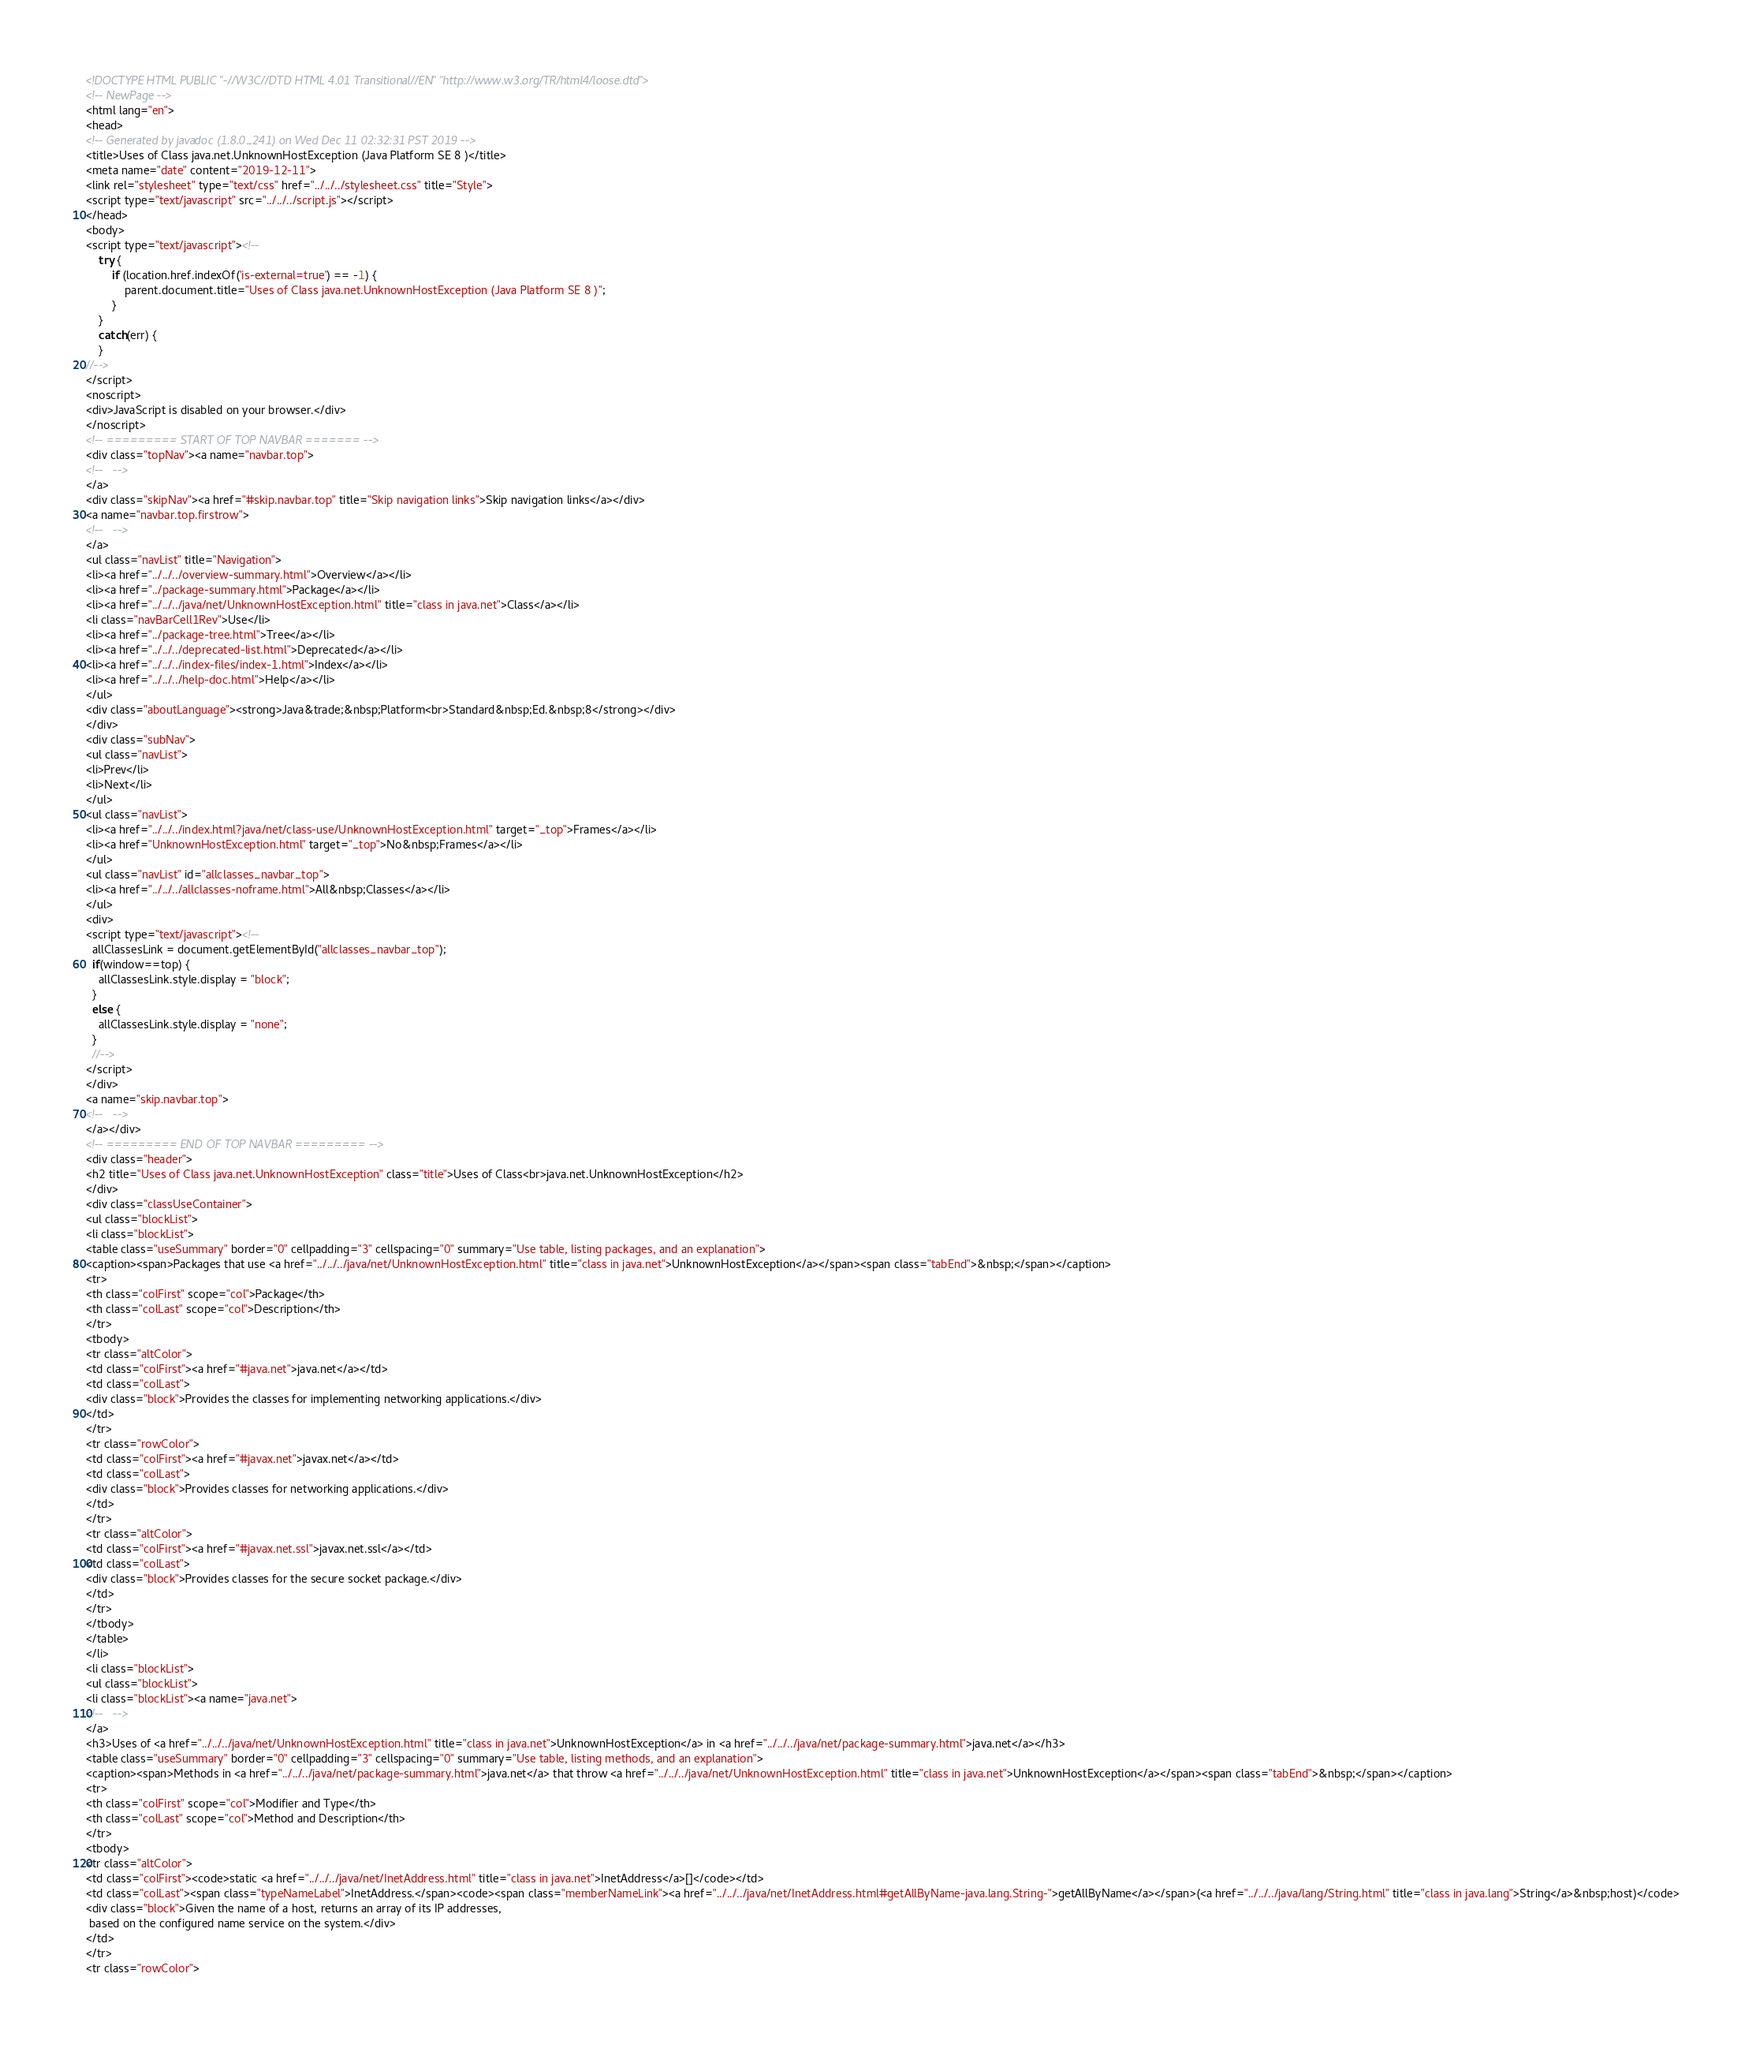Convert code to text. <code><loc_0><loc_0><loc_500><loc_500><_HTML_><!DOCTYPE HTML PUBLIC "-//W3C//DTD HTML 4.01 Transitional//EN" "http://www.w3.org/TR/html4/loose.dtd">
<!-- NewPage -->
<html lang="en">
<head>
<!-- Generated by javadoc (1.8.0_241) on Wed Dec 11 02:32:31 PST 2019 -->
<title>Uses of Class java.net.UnknownHostException (Java Platform SE 8 )</title>
<meta name="date" content="2019-12-11">
<link rel="stylesheet" type="text/css" href="../../../stylesheet.css" title="Style">
<script type="text/javascript" src="../../../script.js"></script>
</head>
<body>
<script type="text/javascript"><!--
    try {
        if (location.href.indexOf('is-external=true') == -1) {
            parent.document.title="Uses of Class java.net.UnknownHostException (Java Platform SE 8 )";
        }
    }
    catch(err) {
    }
//-->
</script>
<noscript>
<div>JavaScript is disabled on your browser.</div>
</noscript>
<!-- ========= START OF TOP NAVBAR ======= -->
<div class="topNav"><a name="navbar.top">
<!--   -->
</a>
<div class="skipNav"><a href="#skip.navbar.top" title="Skip navigation links">Skip navigation links</a></div>
<a name="navbar.top.firstrow">
<!--   -->
</a>
<ul class="navList" title="Navigation">
<li><a href="../../../overview-summary.html">Overview</a></li>
<li><a href="../package-summary.html">Package</a></li>
<li><a href="../../../java/net/UnknownHostException.html" title="class in java.net">Class</a></li>
<li class="navBarCell1Rev">Use</li>
<li><a href="../package-tree.html">Tree</a></li>
<li><a href="../../../deprecated-list.html">Deprecated</a></li>
<li><a href="../../../index-files/index-1.html">Index</a></li>
<li><a href="../../../help-doc.html">Help</a></li>
</ul>
<div class="aboutLanguage"><strong>Java&trade;&nbsp;Platform<br>Standard&nbsp;Ed.&nbsp;8</strong></div>
</div>
<div class="subNav">
<ul class="navList">
<li>Prev</li>
<li>Next</li>
</ul>
<ul class="navList">
<li><a href="../../../index.html?java/net/class-use/UnknownHostException.html" target="_top">Frames</a></li>
<li><a href="UnknownHostException.html" target="_top">No&nbsp;Frames</a></li>
</ul>
<ul class="navList" id="allclasses_navbar_top">
<li><a href="../../../allclasses-noframe.html">All&nbsp;Classes</a></li>
</ul>
<div>
<script type="text/javascript"><!--
  allClassesLink = document.getElementById("allclasses_navbar_top");
  if(window==top) {
    allClassesLink.style.display = "block";
  }
  else {
    allClassesLink.style.display = "none";
  }
  //-->
</script>
</div>
<a name="skip.navbar.top">
<!--   -->
</a></div>
<!-- ========= END OF TOP NAVBAR ========= -->
<div class="header">
<h2 title="Uses of Class java.net.UnknownHostException" class="title">Uses of Class<br>java.net.UnknownHostException</h2>
</div>
<div class="classUseContainer">
<ul class="blockList">
<li class="blockList">
<table class="useSummary" border="0" cellpadding="3" cellspacing="0" summary="Use table, listing packages, and an explanation">
<caption><span>Packages that use <a href="../../../java/net/UnknownHostException.html" title="class in java.net">UnknownHostException</a></span><span class="tabEnd">&nbsp;</span></caption>
<tr>
<th class="colFirst" scope="col">Package</th>
<th class="colLast" scope="col">Description</th>
</tr>
<tbody>
<tr class="altColor">
<td class="colFirst"><a href="#java.net">java.net</a></td>
<td class="colLast">
<div class="block">Provides the classes for implementing networking applications.</div>
</td>
</tr>
<tr class="rowColor">
<td class="colFirst"><a href="#javax.net">javax.net</a></td>
<td class="colLast">
<div class="block">Provides classes for networking applications.</div>
</td>
</tr>
<tr class="altColor">
<td class="colFirst"><a href="#javax.net.ssl">javax.net.ssl</a></td>
<td class="colLast">
<div class="block">Provides classes for the secure socket package.</div>
</td>
</tr>
</tbody>
</table>
</li>
<li class="blockList">
<ul class="blockList">
<li class="blockList"><a name="java.net">
<!--   -->
</a>
<h3>Uses of <a href="../../../java/net/UnknownHostException.html" title="class in java.net">UnknownHostException</a> in <a href="../../../java/net/package-summary.html">java.net</a></h3>
<table class="useSummary" border="0" cellpadding="3" cellspacing="0" summary="Use table, listing methods, and an explanation">
<caption><span>Methods in <a href="../../../java/net/package-summary.html">java.net</a> that throw <a href="../../../java/net/UnknownHostException.html" title="class in java.net">UnknownHostException</a></span><span class="tabEnd">&nbsp;</span></caption>
<tr>
<th class="colFirst" scope="col">Modifier and Type</th>
<th class="colLast" scope="col">Method and Description</th>
</tr>
<tbody>
<tr class="altColor">
<td class="colFirst"><code>static <a href="../../../java/net/InetAddress.html" title="class in java.net">InetAddress</a>[]</code></td>
<td class="colLast"><span class="typeNameLabel">InetAddress.</span><code><span class="memberNameLink"><a href="../../../java/net/InetAddress.html#getAllByName-java.lang.String-">getAllByName</a></span>(<a href="../../../java/lang/String.html" title="class in java.lang">String</a>&nbsp;host)</code>
<div class="block">Given the name of a host, returns an array of its IP addresses,
 based on the configured name service on the system.</div>
</td>
</tr>
<tr class="rowColor"></code> 